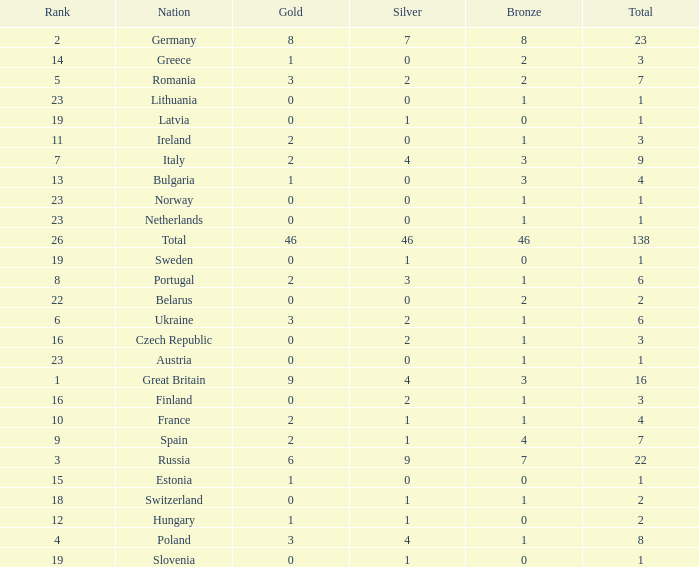What is the total number for a total when the nation is netherlands and silver is larger than 0? 0.0. 